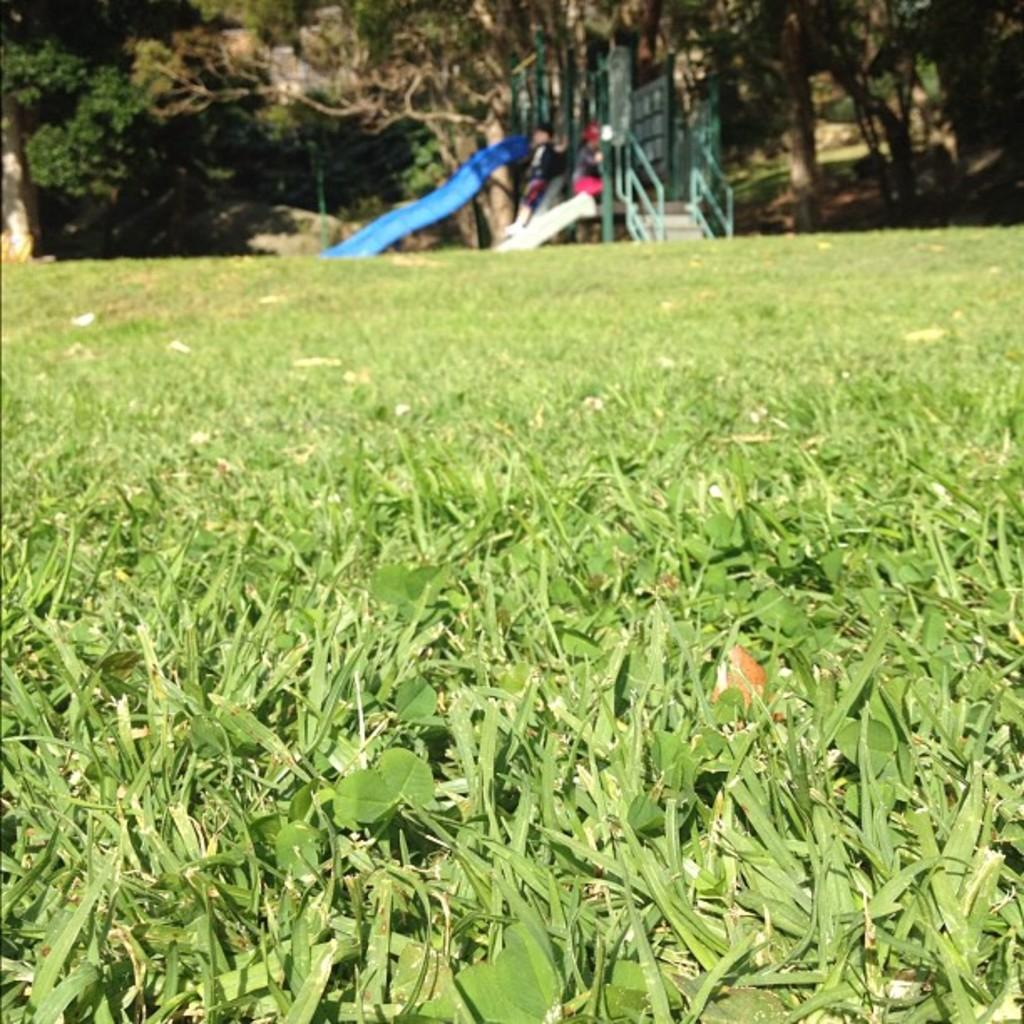What type of natural environment is visible at the bottom of the image? There is grass and leaves visible at the bottom of the image. What type of plant is visible at the top of the image? There is a tree visible at the top of the image. Who is present in the image? There are children visible in the image. What architectural feature is visible in the image? There are steps visible in the image. What type of letter is being recited by the children in the image? There is no indication in the image that the children are reciting a letter or any form of text. Can you hear the verse being sung by the children in the image? The image is static, and there is no audio associated with it, so it is not possible to hear any singing or verses. 